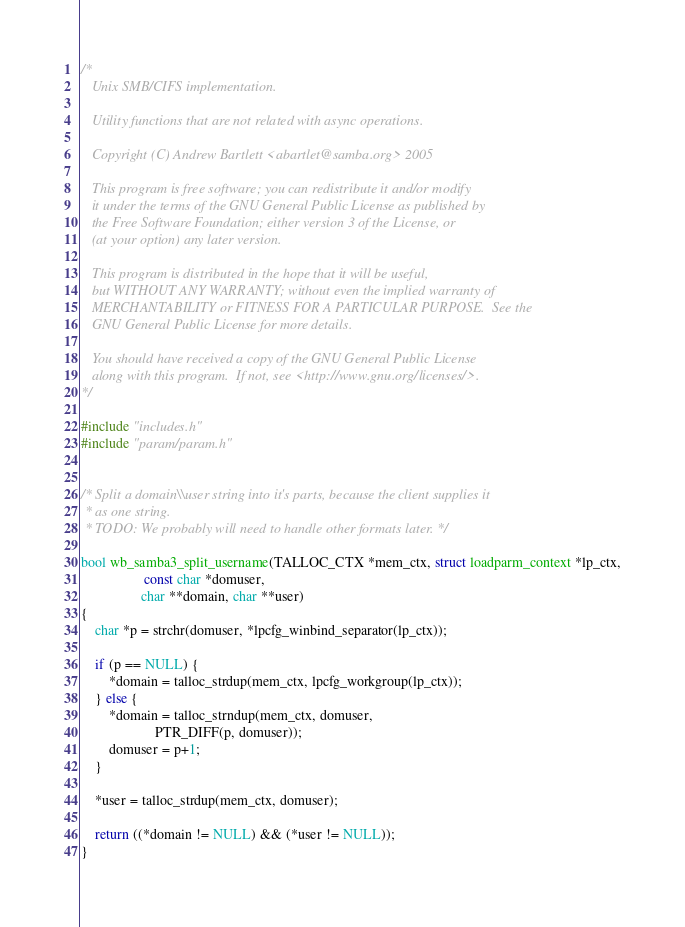Convert code to text. <code><loc_0><loc_0><loc_500><loc_500><_C_>/*
   Unix SMB/CIFS implementation.

   Utility functions that are not related with async operations.

   Copyright (C) Andrew Bartlett <abartlet@samba.org> 2005

   This program is free software; you can redistribute it and/or modify
   it under the terms of the GNU General Public License as published by
   the Free Software Foundation; either version 3 of the License, or
   (at your option) any later version.

   This program is distributed in the hope that it will be useful,
   but WITHOUT ANY WARRANTY; without even the implied warranty of
   MERCHANTABILITY or FITNESS FOR A PARTICULAR PURPOSE.  See the
   GNU General Public License for more details.

   You should have received a copy of the GNU General Public License
   along with this program.  If not, see <http://www.gnu.org/licenses/>.
*/

#include "includes.h"
#include "param/param.h"


/* Split a domain\\user string into it's parts, because the client supplies it
 * as one string.
 * TODO: We probably will need to handle other formats later. */

bool wb_samba3_split_username(TALLOC_CTX *mem_ctx, struct loadparm_context *lp_ctx,
			      const char *domuser,
				 char **domain, char **user)
{
	char *p = strchr(domuser, *lpcfg_winbind_separator(lp_ctx));

	if (p == NULL) {
		*domain = talloc_strdup(mem_ctx, lpcfg_workgroup(lp_ctx));
	} else {
		*domain = talloc_strndup(mem_ctx, domuser,
					 PTR_DIFF(p, domuser));
		domuser = p+1;
	}

	*user = talloc_strdup(mem_ctx, domuser);

	return ((*domain != NULL) && (*user != NULL));
}


</code> 